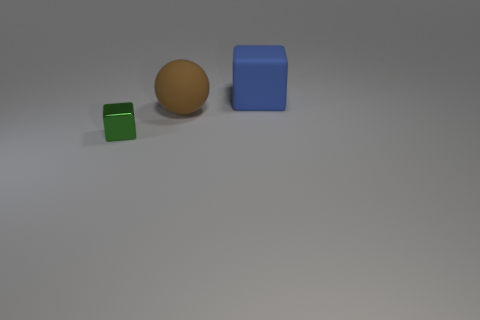Are there any other things that are made of the same material as the green thing?
Provide a short and direct response. No. Is there any other thing that has the same size as the shiny cube?
Keep it short and to the point. No. Do the brown rubber sphere and the green object have the same size?
Your response must be concise. No. What number of cylinders are tiny yellow metallic things or brown rubber objects?
Your response must be concise. 0. How many large matte things are the same shape as the tiny object?
Ensure brevity in your answer.  1. Are there more cubes in front of the big brown thing than rubber balls that are in front of the metal cube?
Ensure brevity in your answer.  Yes. There is a large thing that is in front of the big block; is its color the same as the shiny cube?
Your answer should be compact. No. What size is the brown rubber object?
Ensure brevity in your answer.  Large. There is another thing that is the same size as the blue matte object; what material is it?
Make the answer very short. Rubber. What color is the cube in front of the big brown matte thing?
Your response must be concise. Green. 